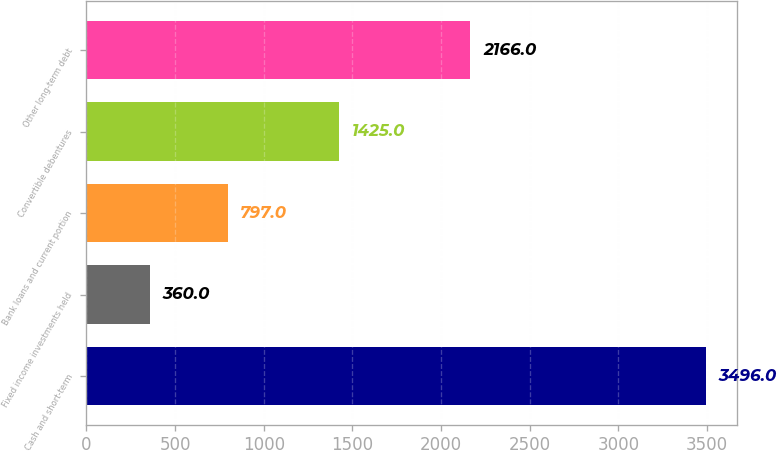Convert chart to OTSL. <chart><loc_0><loc_0><loc_500><loc_500><bar_chart><fcel>Cash and short-term<fcel>Fixed income investments held<fcel>Bank loans and current portion<fcel>Convertible debentures<fcel>Other long-term debt<nl><fcel>3496<fcel>360<fcel>797<fcel>1425<fcel>2166<nl></chart> 